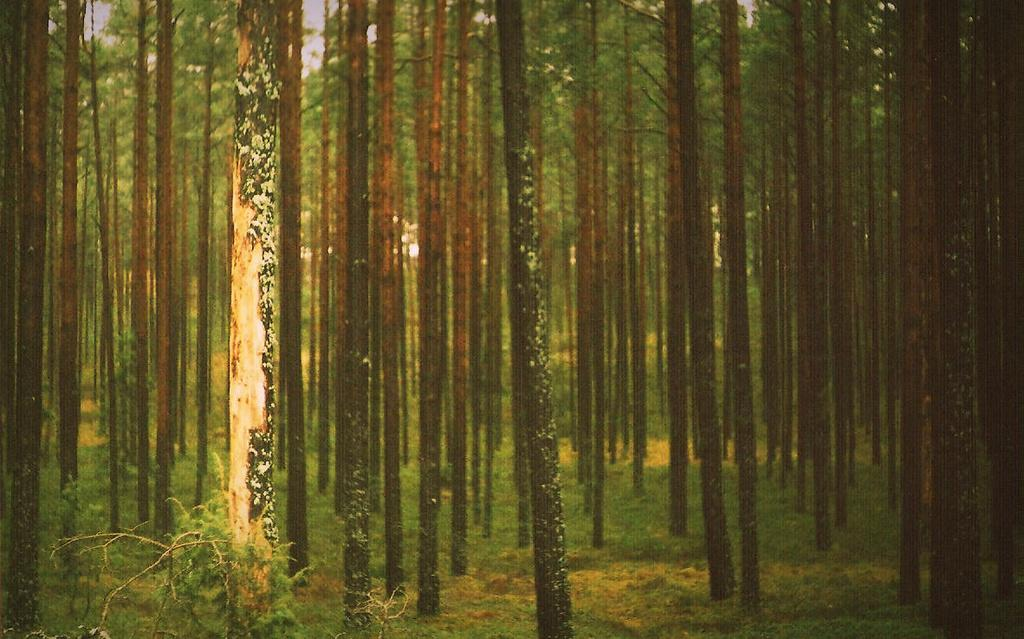What type of vegetation can be seen in the image? There are trees in the image. What else can be seen on the ground in the image? There is grass in the image. What type of order is being followed by the playground equipment in the image? There is no playground equipment present in the image, so it is not possible to determine if any order is being followed. 